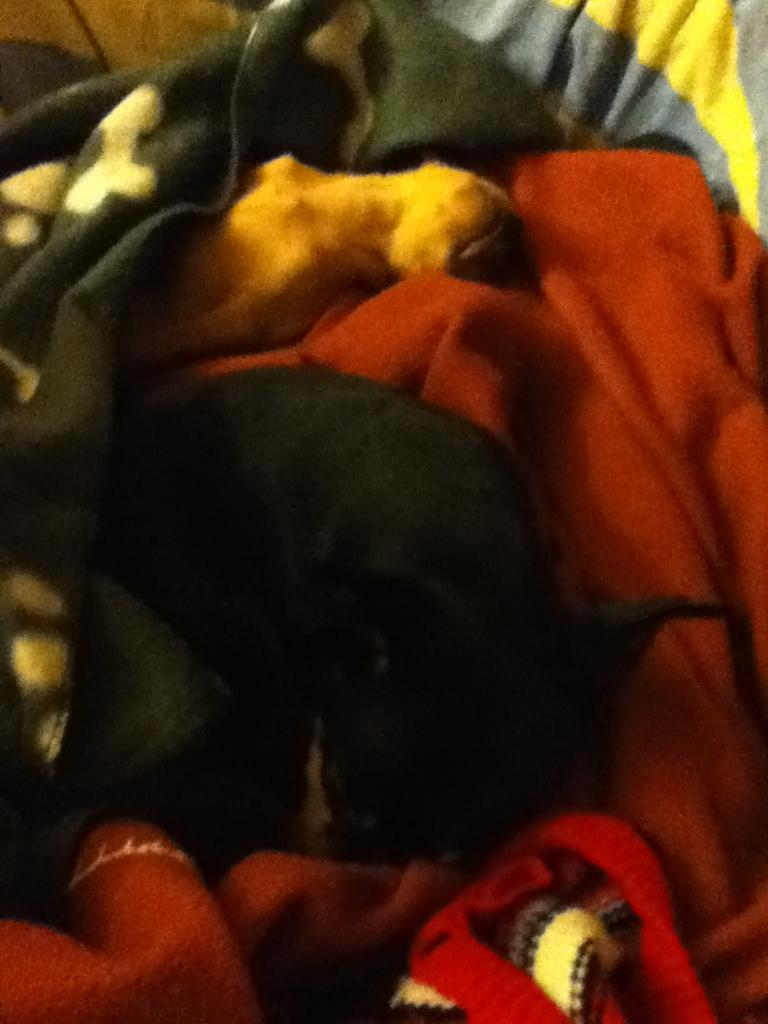How many animals are present in the image? There are two animals in the image. What are the animals doing or situated on in the image? The animals are on blankets. What type of vegetable is growing on the bridge in the image? There is no bridge or vegetable present in the image. What type of loss is the animal experiencing in the image? There is no indication of any loss experienced by the animals in the image. 